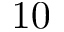Convert formula to latex. <formula><loc_0><loc_0><loc_500><loc_500>1 0</formula> 